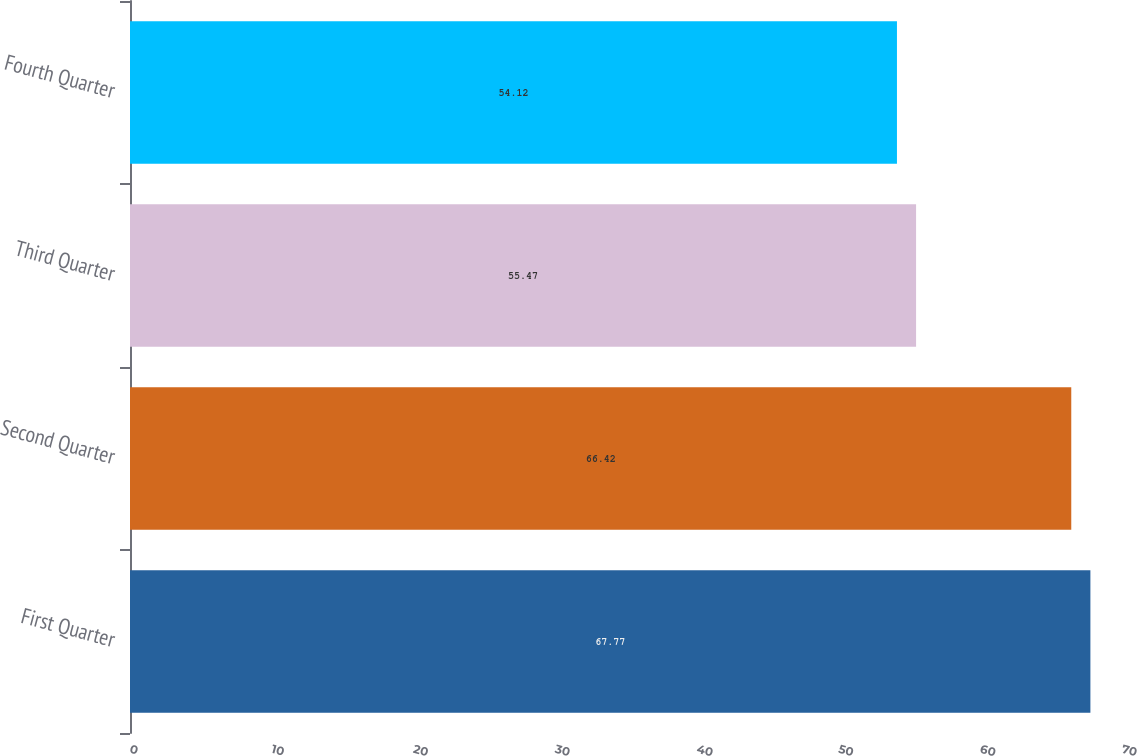Convert chart. <chart><loc_0><loc_0><loc_500><loc_500><bar_chart><fcel>First Quarter<fcel>Second Quarter<fcel>Third Quarter<fcel>Fourth Quarter<nl><fcel>67.77<fcel>66.42<fcel>55.47<fcel>54.12<nl></chart> 